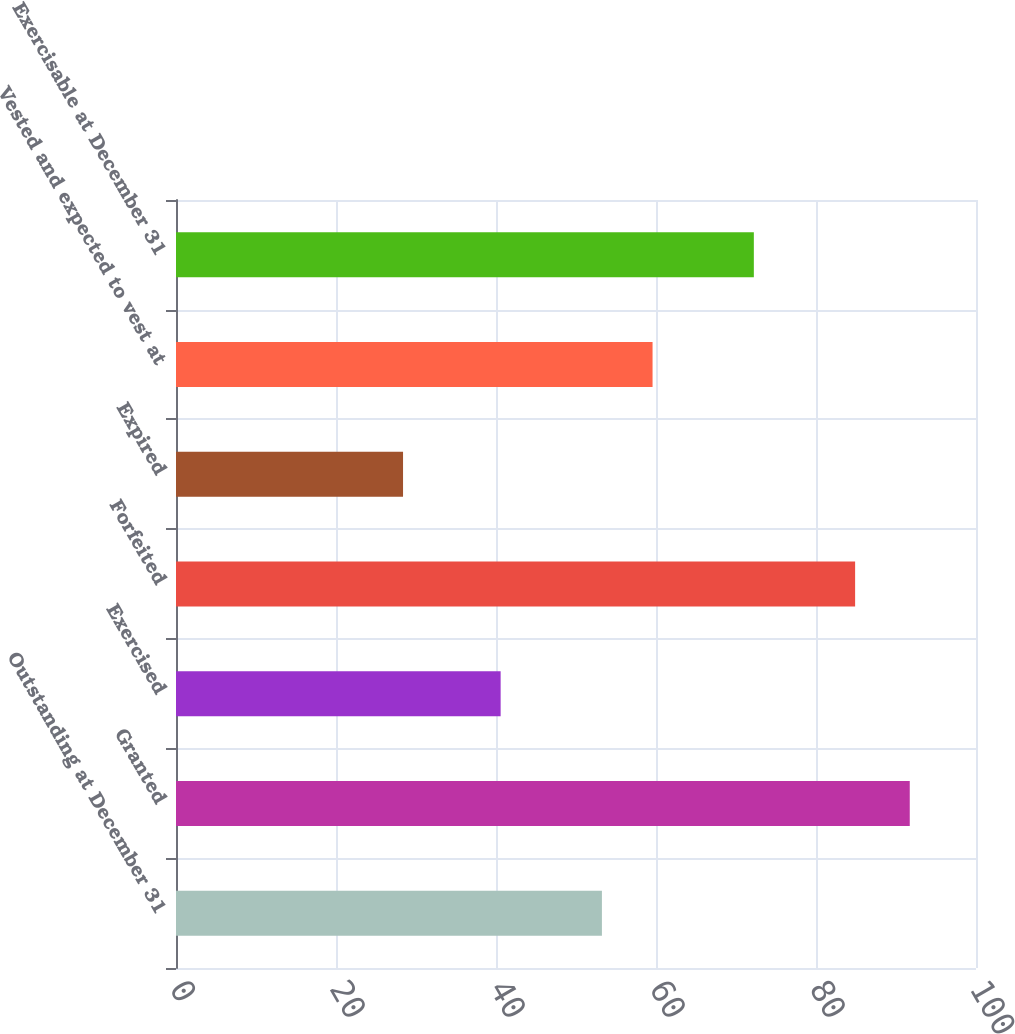<chart> <loc_0><loc_0><loc_500><loc_500><bar_chart><fcel>Outstanding at December 31<fcel>Granted<fcel>Exercised<fcel>Forfeited<fcel>Expired<fcel>Vested and expected to vest at<fcel>Exercisable at December 31<nl><fcel>53.24<fcel>91.72<fcel>40.58<fcel>84.89<fcel>28.38<fcel>59.57<fcel>72.23<nl></chart> 